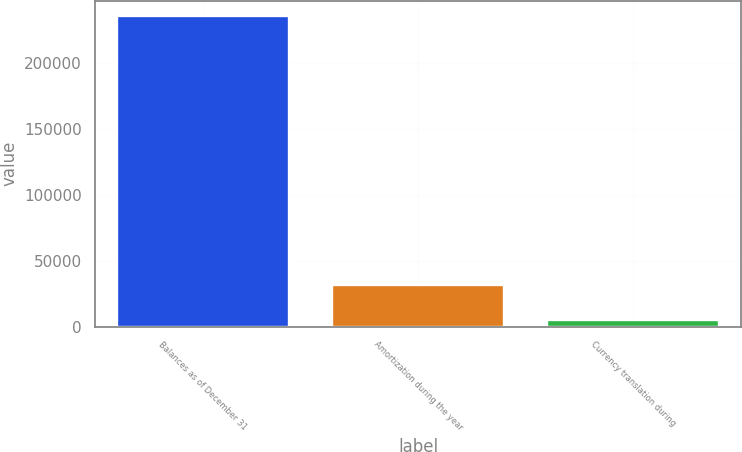<chart> <loc_0><loc_0><loc_500><loc_500><bar_chart><fcel>Balances as of December 31<fcel>Amortization during the year<fcel>Currency translation during<nl><fcel>235704<fcel>31704.1<fcel>5102<nl></chart> 